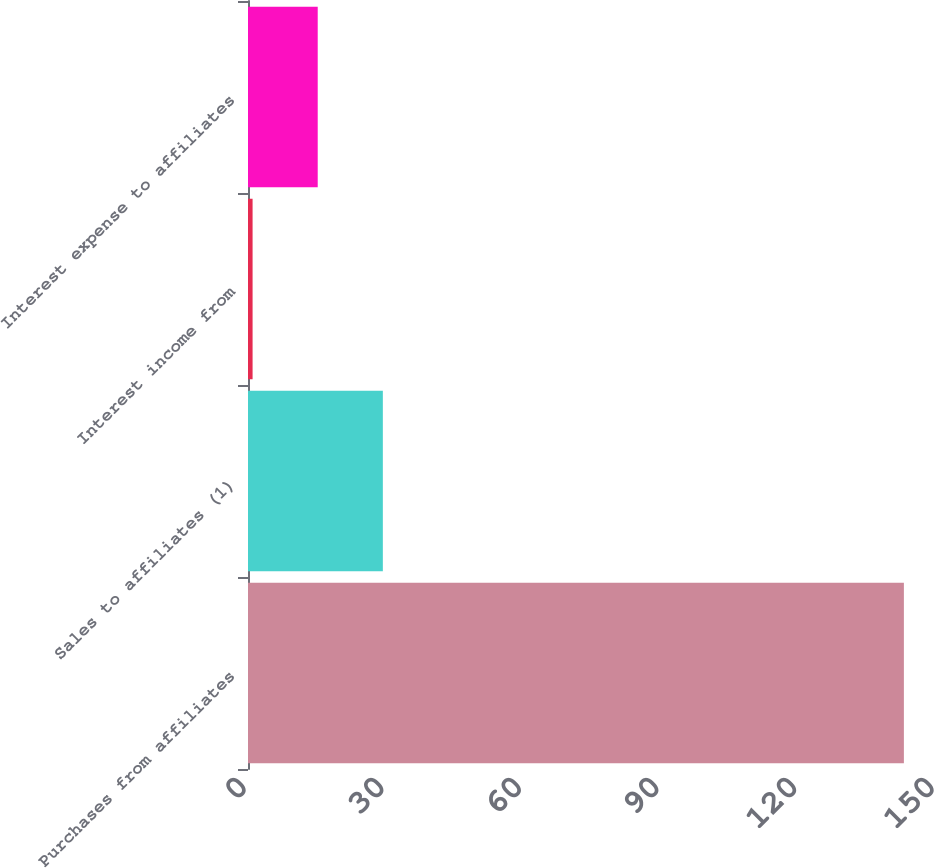<chart> <loc_0><loc_0><loc_500><loc_500><bar_chart><fcel>Purchases from affiliates<fcel>Sales to affiliates (1)<fcel>Interest income from<fcel>Interest expense to affiliates<nl><fcel>143<fcel>29.4<fcel>1<fcel>15.2<nl></chart> 